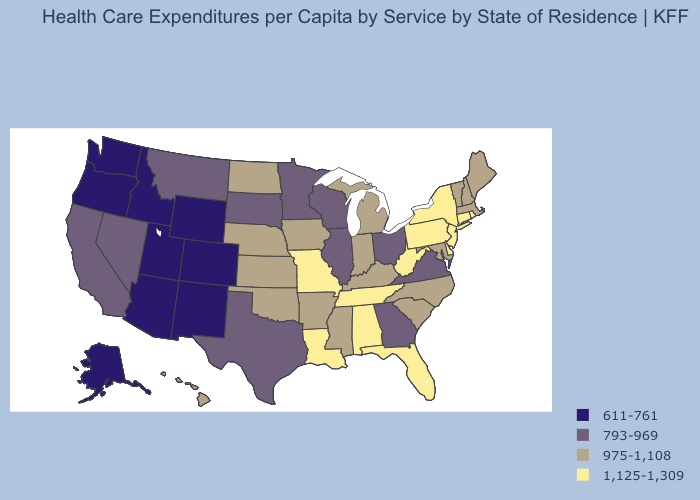What is the value of Tennessee?
Quick response, please. 1,125-1,309. Which states have the lowest value in the USA?
Answer briefly. Alaska, Arizona, Colorado, Idaho, New Mexico, Oregon, Utah, Washington, Wyoming. What is the lowest value in states that border Washington?
Short answer required. 611-761. Name the states that have a value in the range 975-1,108?
Concise answer only. Arkansas, Hawaii, Indiana, Iowa, Kansas, Kentucky, Maine, Maryland, Massachusetts, Michigan, Mississippi, Nebraska, New Hampshire, North Carolina, North Dakota, Oklahoma, South Carolina, Vermont. What is the value of South Dakota?
Be succinct. 793-969. Which states have the lowest value in the USA?
Write a very short answer. Alaska, Arizona, Colorado, Idaho, New Mexico, Oregon, Utah, Washington, Wyoming. Name the states that have a value in the range 611-761?
Short answer required. Alaska, Arizona, Colorado, Idaho, New Mexico, Oregon, Utah, Washington, Wyoming. Does New York have the lowest value in the Northeast?
Concise answer only. No. Among the states that border Arizona , does Utah have the lowest value?
Be succinct. Yes. What is the highest value in states that border Washington?
Answer briefly. 611-761. What is the lowest value in states that border Montana?
Concise answer only. 611-761. What is the value of California?
Be succinct. 793-969. What is the value of Delaware?
Quick response, please. 1,125-1,309. What is the value of Ohio?
Short answer required. 793-969. Among the states that border Kentucky , does Ohio have the lowest value?
Short answer required. Yes. 